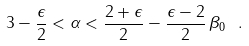Convert formula to latex. <formula><loc_0><loc_0><loc_500><loc_500>3 - \frac { \epsilon } { 2 } < \alpha < \frac { 2 + \epsilon } { 2 } - \frac { \epsilon - 2 } { 2 } \, \beta _ { 0 } \ .</formula> 